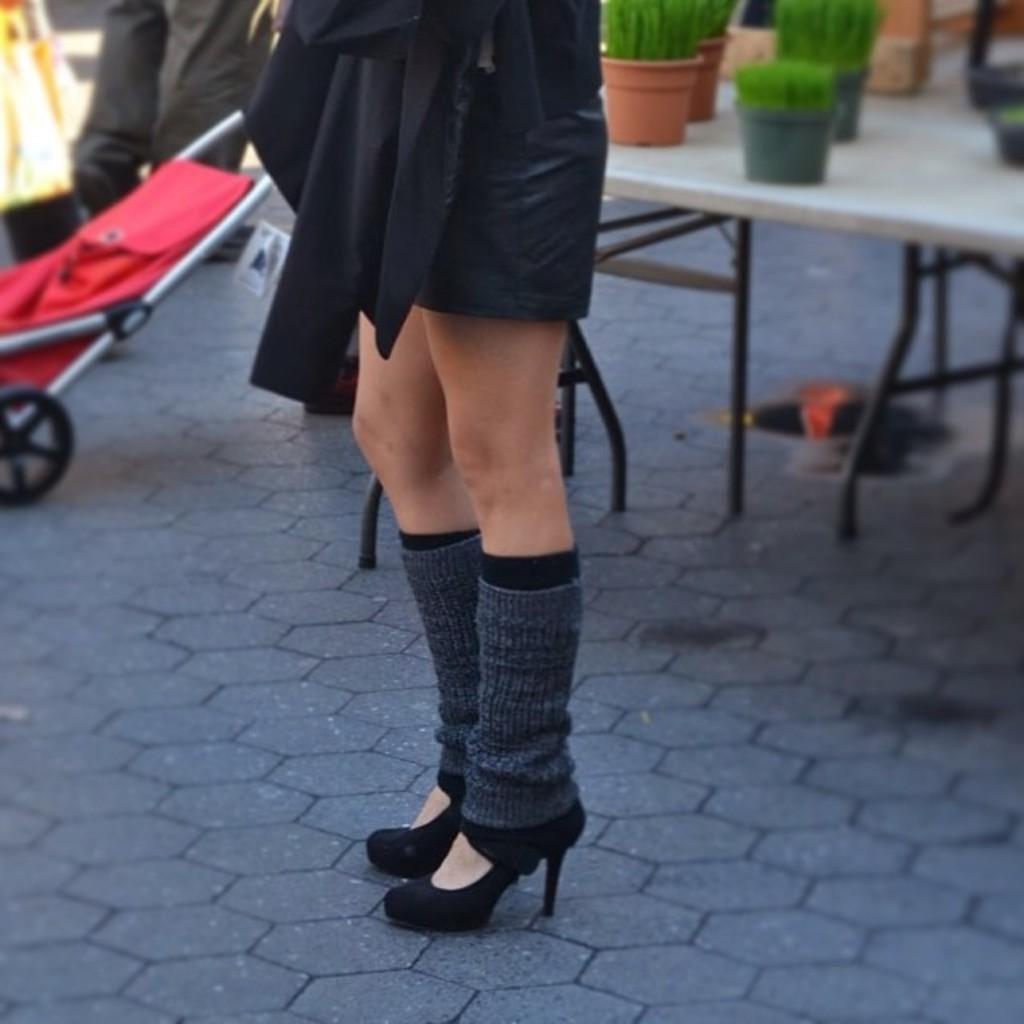Can you describe this image briefly? In this image we can see the person's legs on the floor. And at the back we can see the potted plants on the table. And at the side, we can see the stroller chair. 